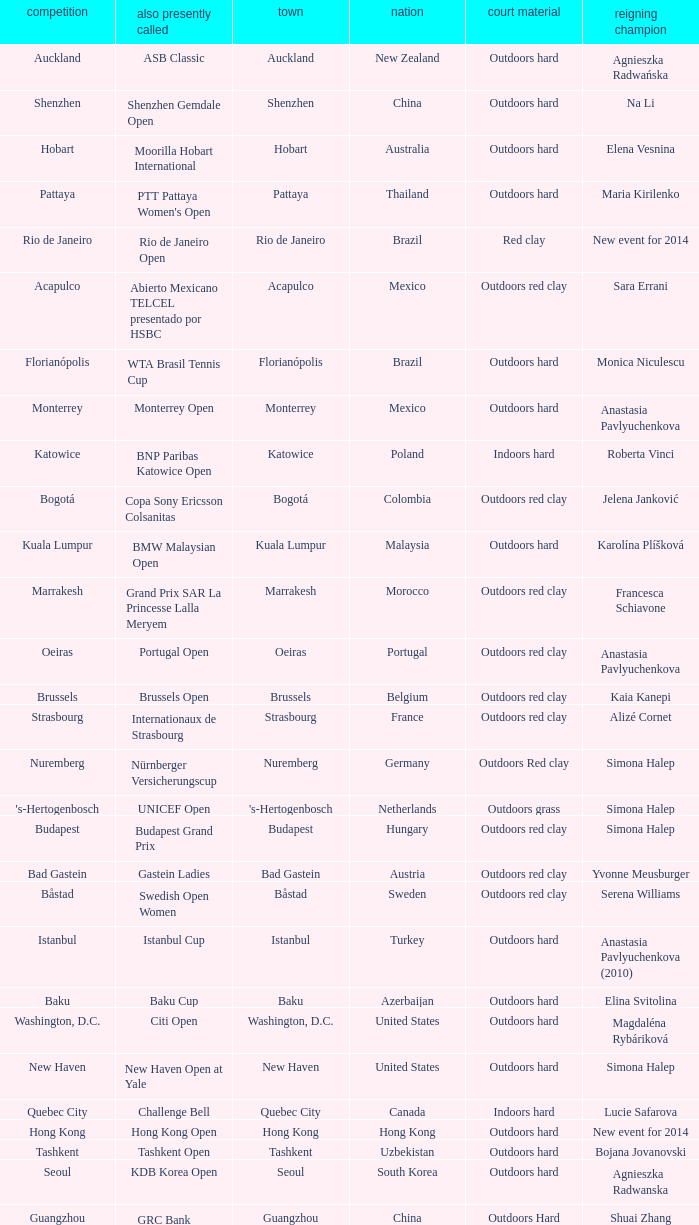How many tournaments are also currently known as the hp open? 1.0. 